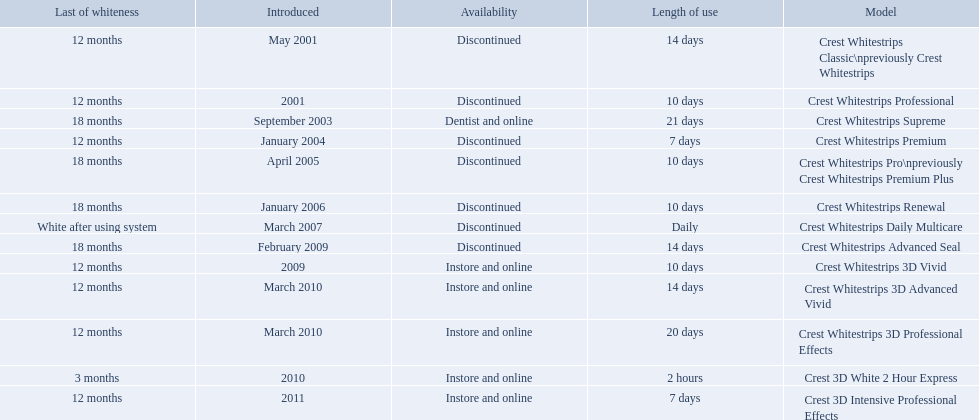When was crest whitestrips 3d advanced vivid introduced? March 2010. What other product was introduced in march 2010? Crest Whitestrips 3D Professional Effects. What are all of the model names? Crest Whitestrips Classic\npreviously Crest Whitestrips, Crest Whitestrips Professional, Crest Whitestrips Supreme, Crest Whitestrips Premium, Crest Whitestrips Pro\npreviously Crest Whitestrips Premium Plus, Crest Whitestrips Renewal, Crest Whitestrips Daily Multicare, Crest Whitestrips Advanced Seal, Crest Whitestrips 3D Vivid, Crest Whitestrips 3D Advanced Vivid, Crest Whitestrips 3D Professional Effects, Crest 3D White 2 Hour Express, Crest 3D Intensive Professional Effects. When were they first introduced? May 2001, 2001, September 2003, January 2004, April 2005, January 2006, March 2007, February 2009, 2009, March 2010, March 2010, 2010, 2011. Along with crest whitestrips 3d advanced vivid, which other model was introduced in march 2010? Crest Whitestrips 3D Professional Effects. 